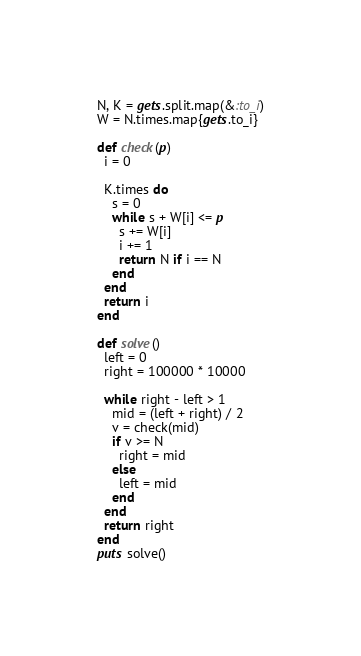<code> <loc_0><loc_0><loc_500><loc_500><_Ruby_>N, K = gets.split.map(&:to_i)
W = N.times.map{gets.to_i}

def check(p)
  i = 0

  K.times do
    s = 0
    while s + W[i] <= p
      s += W[i]
      i += 1
      return N if i == N
    end
  end
  return i
end

def solve()
  left = 0
  right = 100000 * 10000

  while right - left > 1
    mid = (left + right) / 2
    v = check(mid)
    if v >= N
      right = mid
    else
      left = mid
    end
  end
  return right
end
puts solve()
</code> 